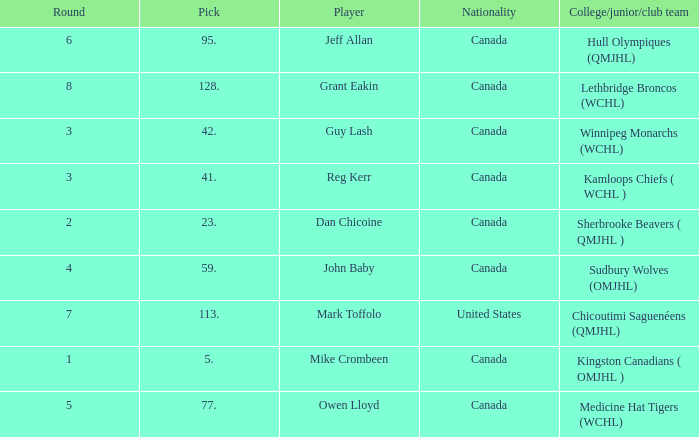Which College/junior/club team has a Round of 2? Sherbrooke Beavers ( QMJHL ). 